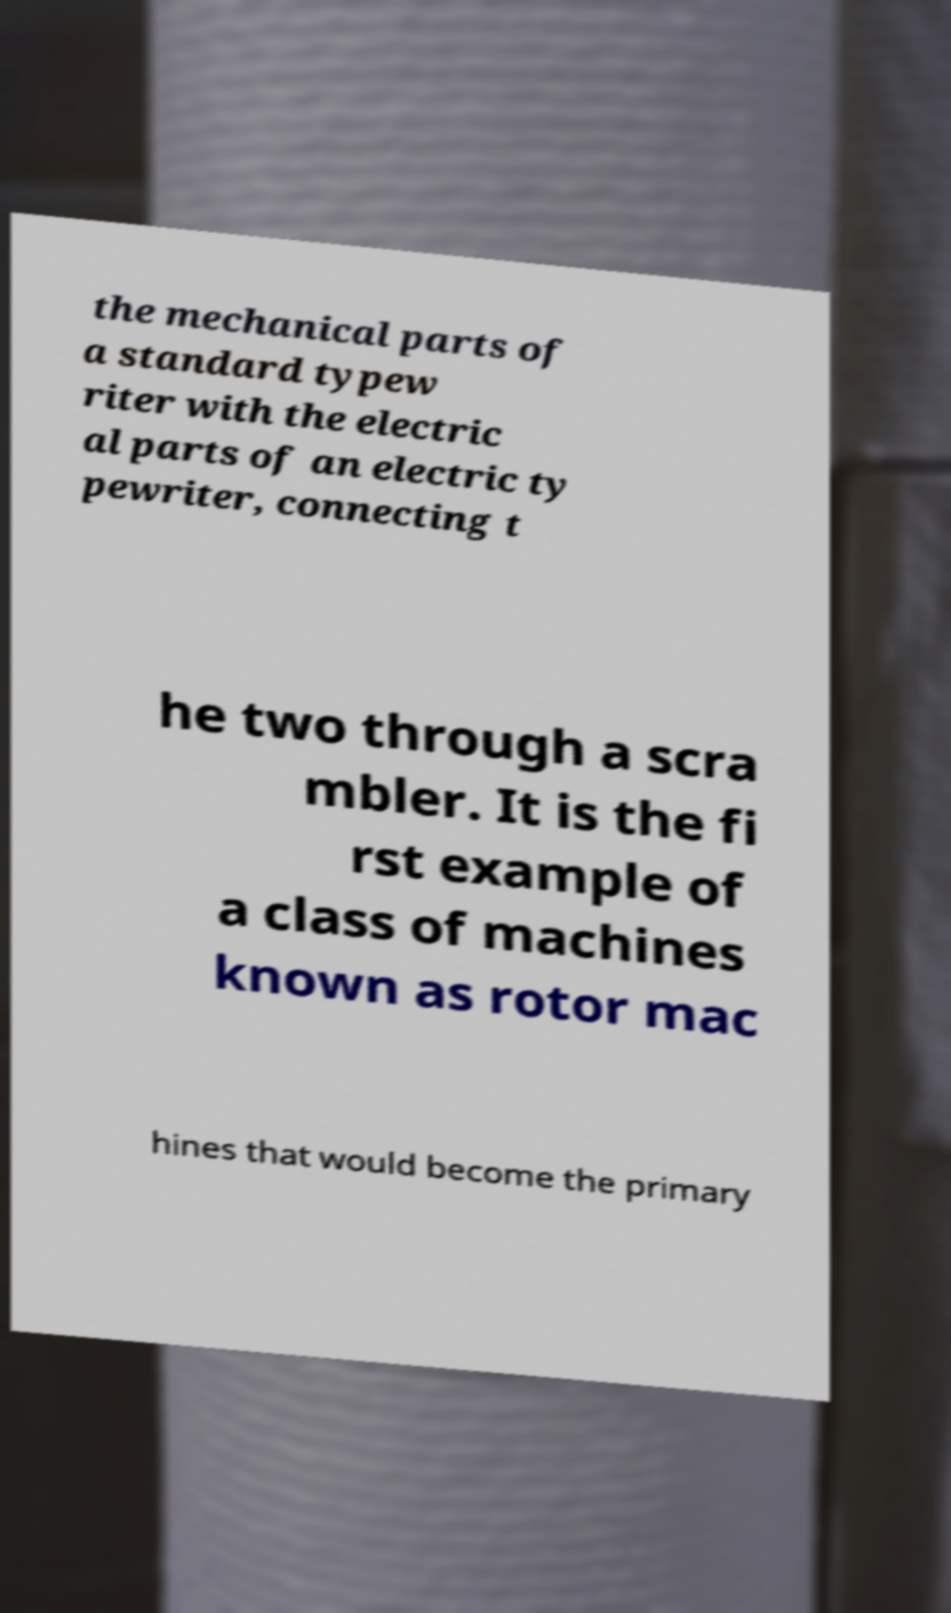Can you read and provide the text displayed in the image?This photo seems to have some interesting text. Can you extract and type it out for me? the mechanical parts of a standard typew riter with the electric al parts of an electric ty pewriter, connecting t he two through a scra mbler. It is the fi rst example of a class of machines known as rotor mac hines that would become the primary 